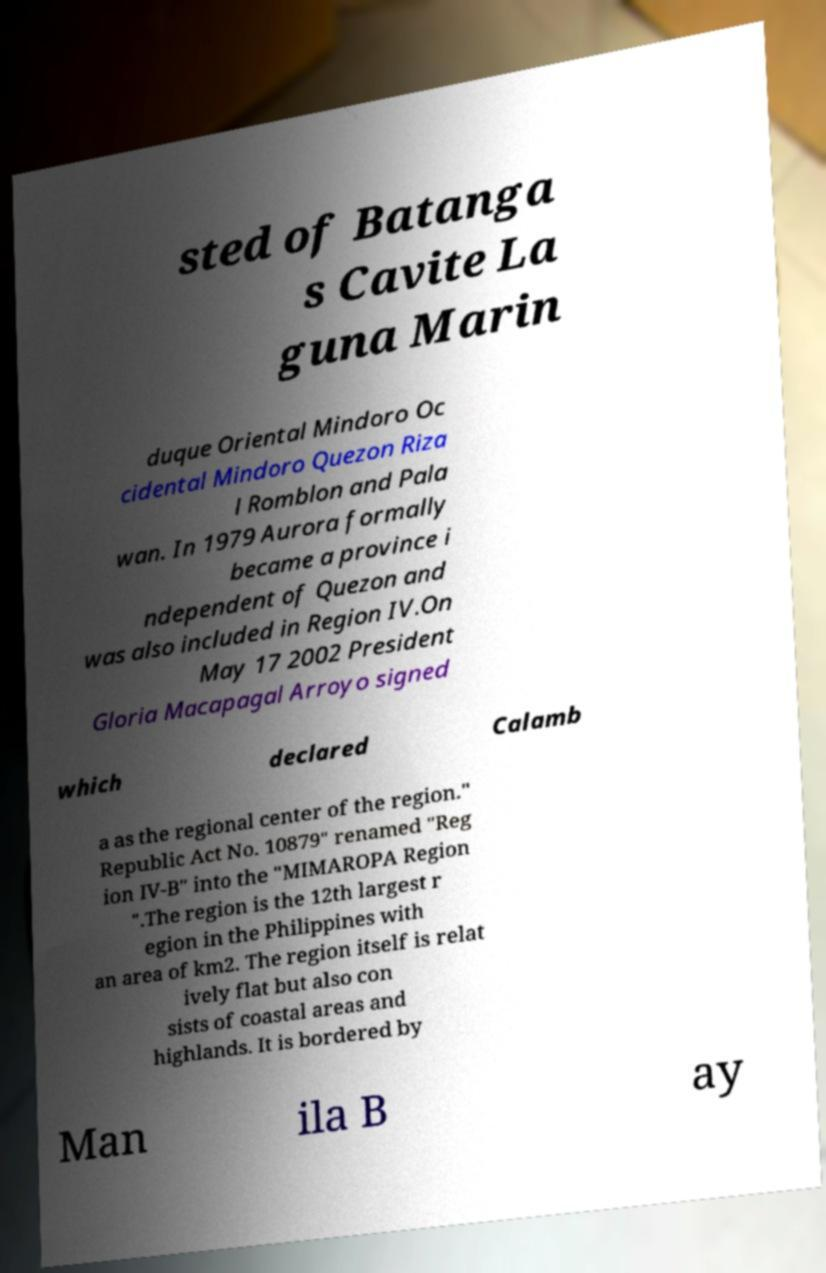What messages or text are displayed in this image? I need them in a readable, typed format. sted of Batanga s Cavite La guna Marin duque Oriental Mindoro Oc cidental Mindoro Quezon Riza l Romblon and Pala wan. In 1979 Aurora formally became a province i ndependent of Quezon and was also included in Region IV.On May 17 2002 President Gloria Macapagal Arroyo signed which declared Calamb a as the regional center of the region." Republic Act No. 10879" renamed "Reg ion IV-B" into the "MIMAROPA Region ".The region is the 12th largest r egion in the Philippines with an area of km2. The region itself is relat ively flat but also con sists of coastal areas and highlands. It is bordered by Man ila B ay 